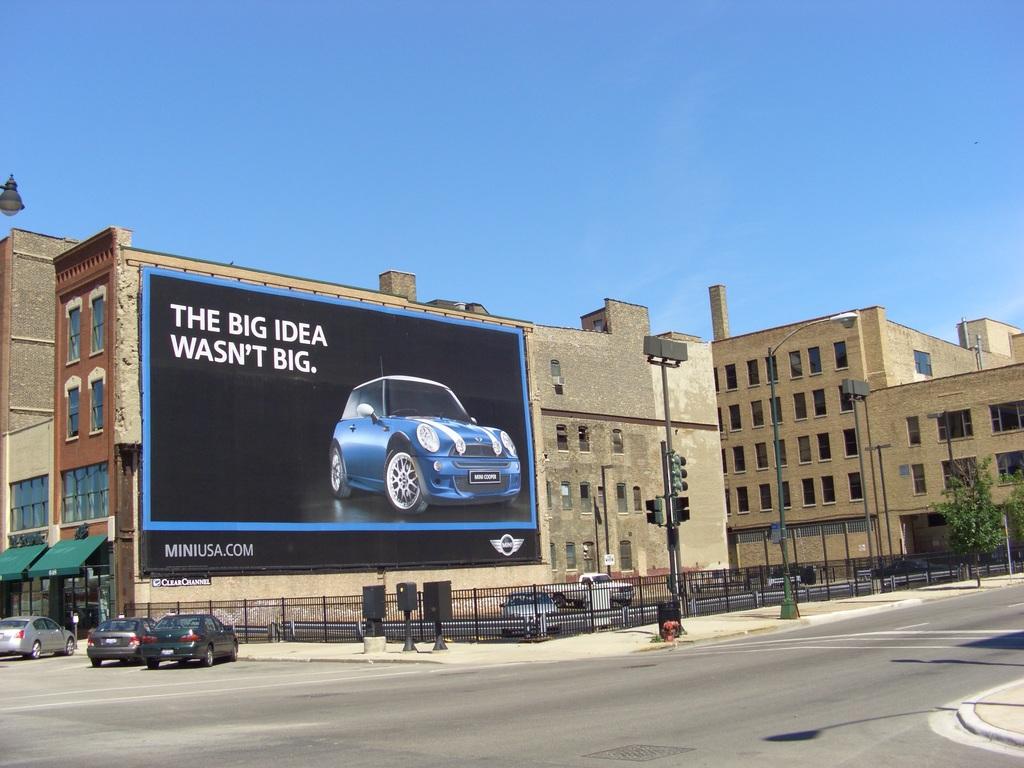What is the web address on the sign?
Keep it short and to the point. Miniusa.com. 